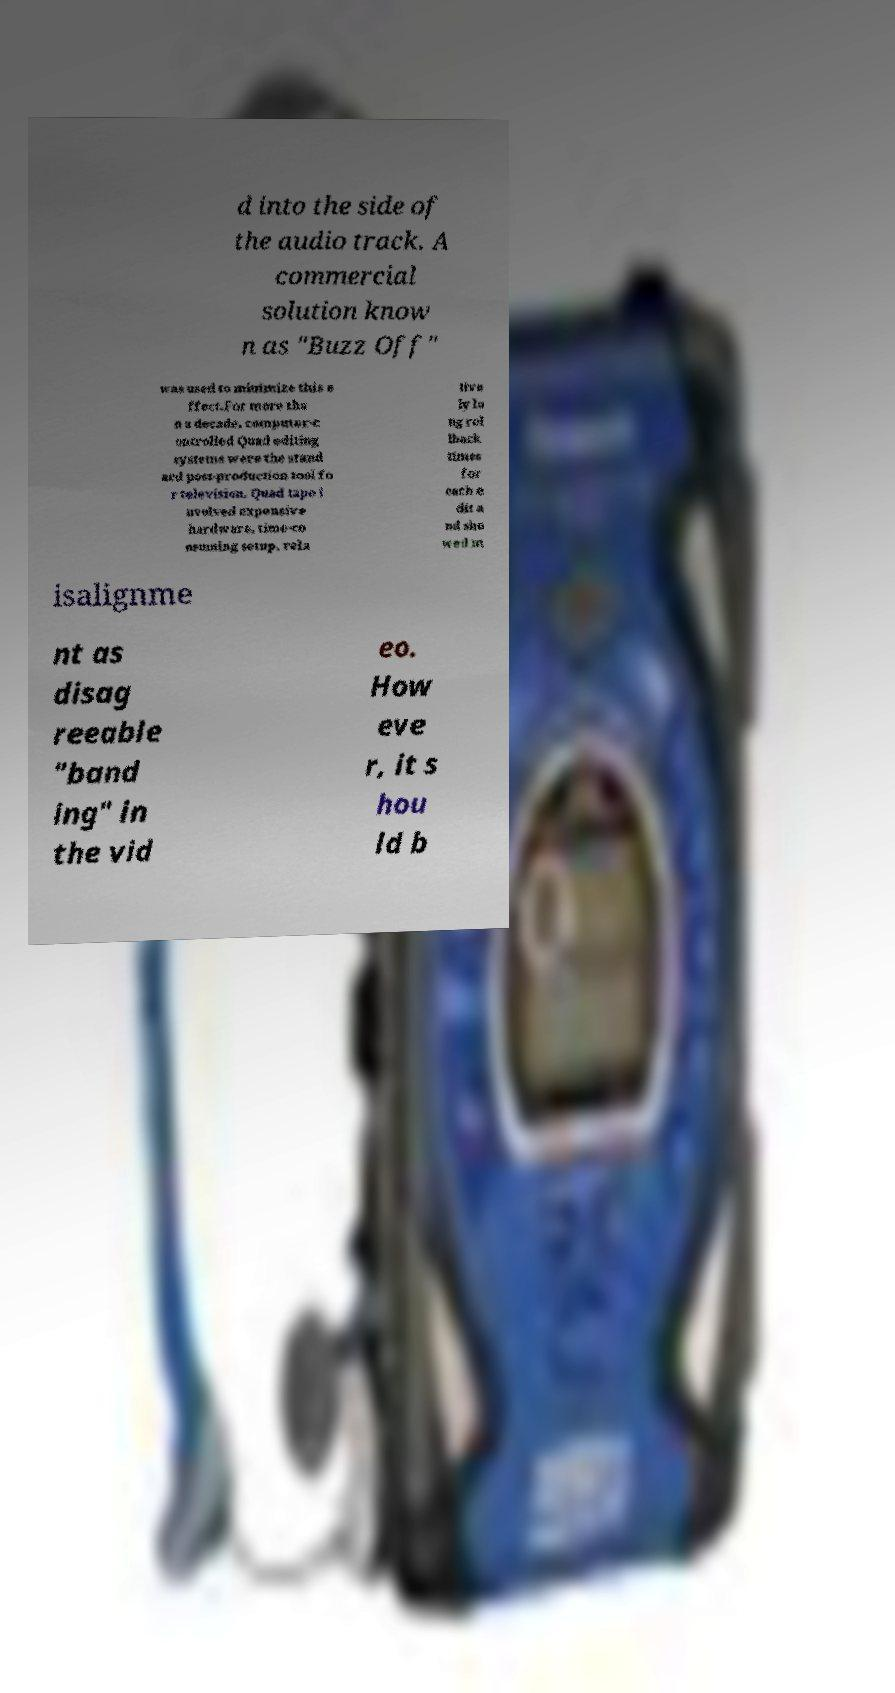Can you accurately transcribe the text from the provided image for me? d into the side of the audio track. A commercial solution know n as "Buzz Off" was used to minimize this e ffect.For more tha n a decade, computer-c ontrolled Quad editing systems were the stand ard post-production tool fo r television. Quad tape i nvolved expensive hardware, time-co nsuming setup, rela tive ly lo ng rol lback times for each e dit a nd sho wed m isalignme nt as disag reeable "band ing" in the vid eo. How eve r, it s hou ld b 